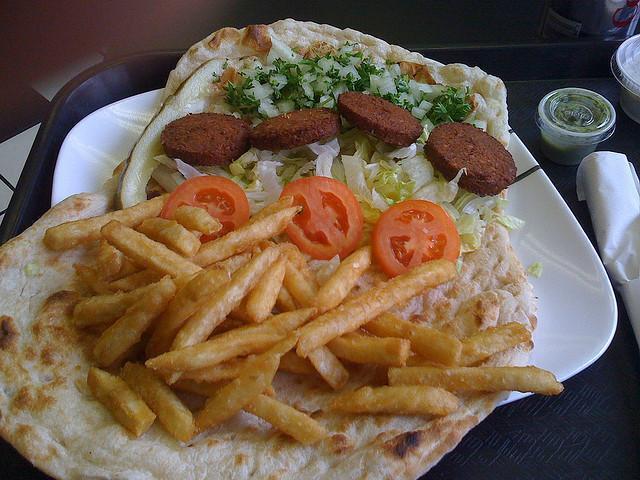How many tomatoes are there?
Give a very brief answer. 3. How many decks does the bus have?
Give a very brief answer. 0. 